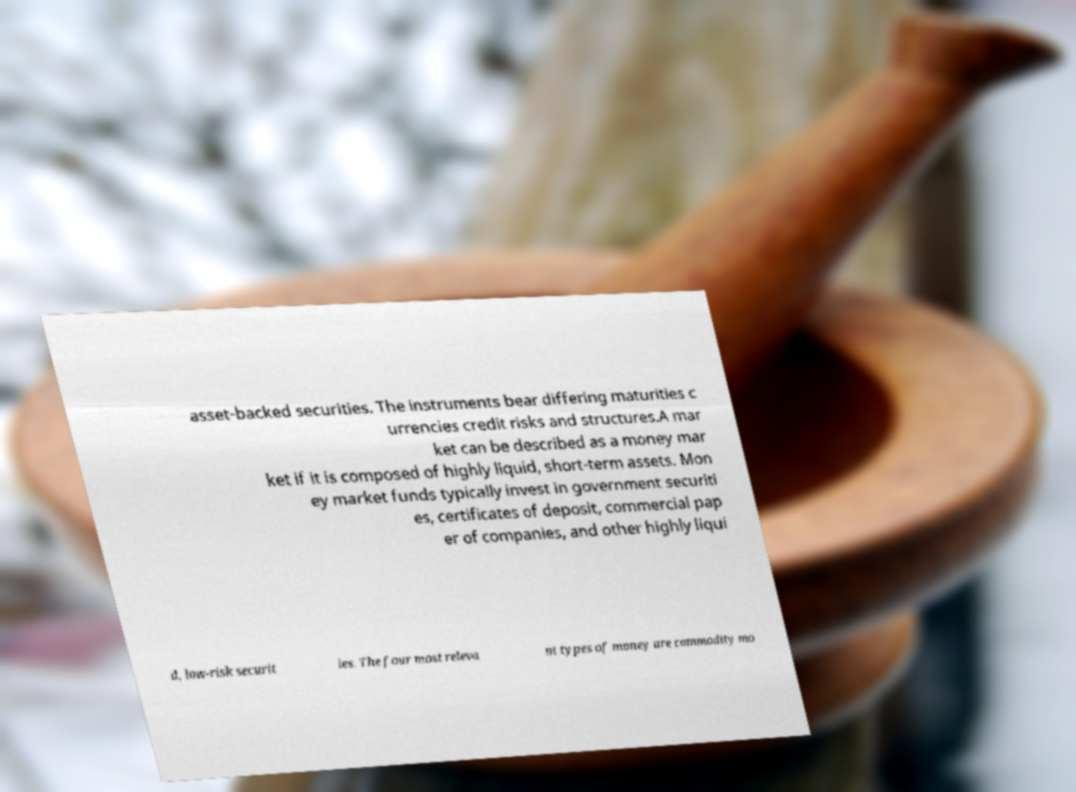For documentation purposes, I need the text within this image transcribed. Could you provide that? asset-backed securities. The instruments bear differing maturities c urrencies credit risks and structures.A mar ket can be described as a money mar ket if it is composed of highly liquid, short-term assets. Mon ey market funds typically invest in government securiti es, certificates of deposit, commercial pap er of companies, and other highly liqui d, low-risk securit ies. The four most releva nt types of money are commodity mo 